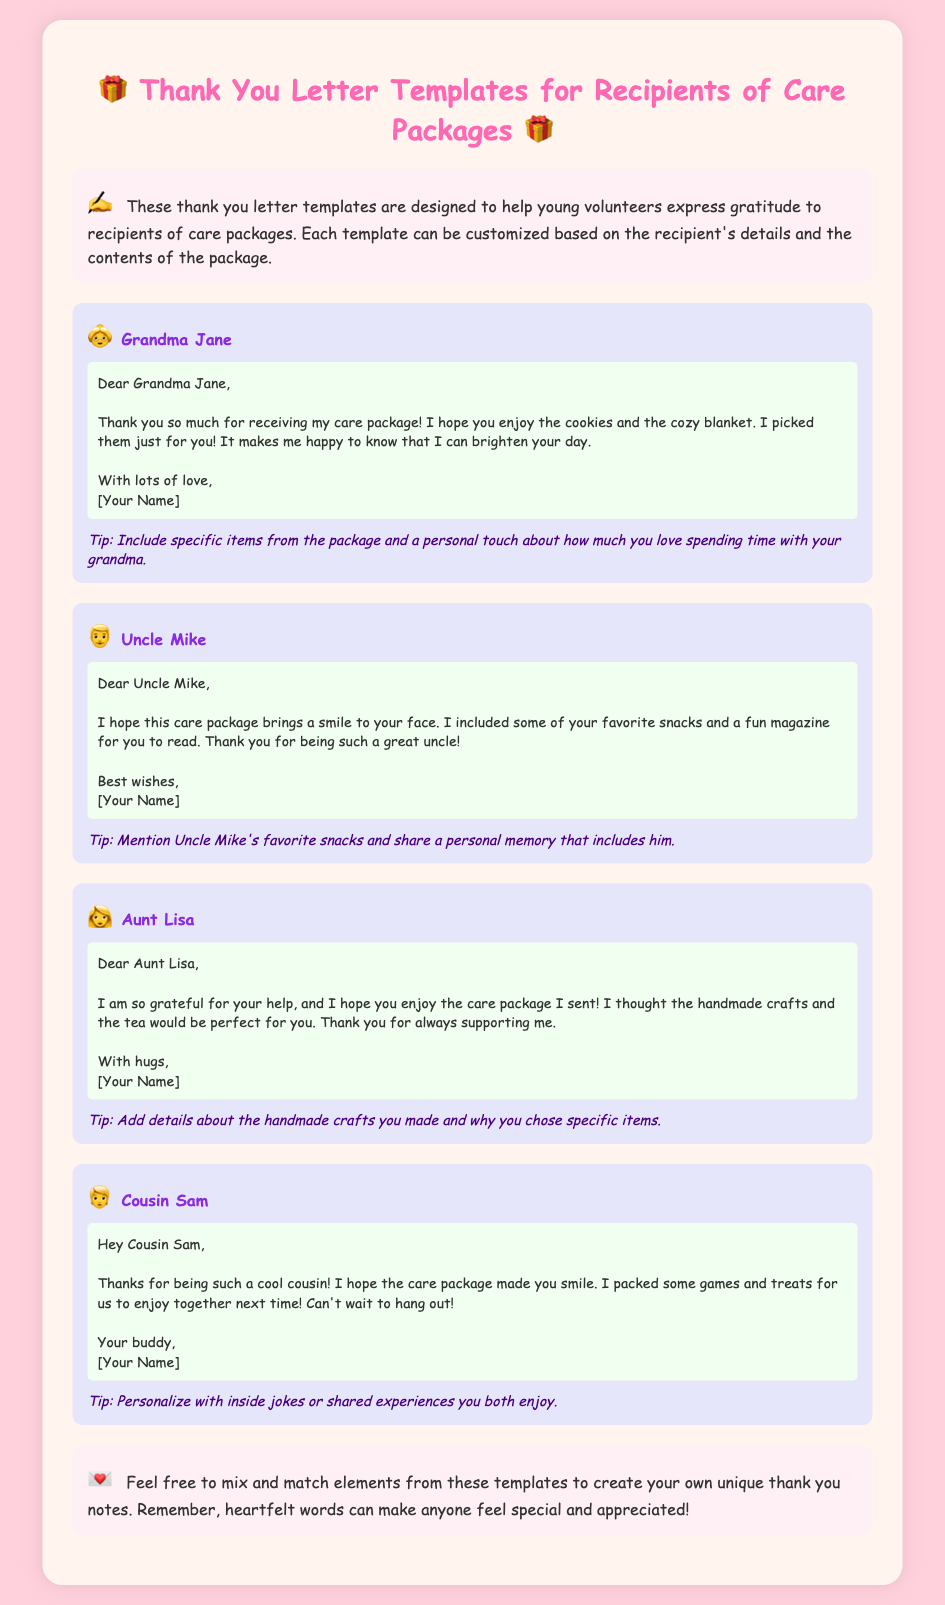What is the title of the document? The title is found in the head section and is displayed prominently at the top of the document.
Answer: Thank You Letter Templates for Recipients of Care Packages How many templates are provided in the document? The document contains a section with multiple templates, counting each unique template displayed.
Answer: 4 What emoji is used for Grandma Jane's template? The emoji associated with Grandma Jane's template is visual in the recipient's section.
Answer: 👵 What is a tip provided for Uncle Mike's letter? The tip can be found just below the message for Uncle Mike, offering a specific suggestion.
Answer: Mention Uncle Mike's favorite snacks and share a personal memory that includes him What color is the background of the introductory section? The color can be observed visually when looking at the design of the introductory section in the document.
Answer: #FFF0F5 What is suggested as a way to personalize Cousin Sam's letter? The personalization strategy can be found in the customization section of Cousin Sam’s template.
Answer: Inside jokes or shared experiences you both enjoy 